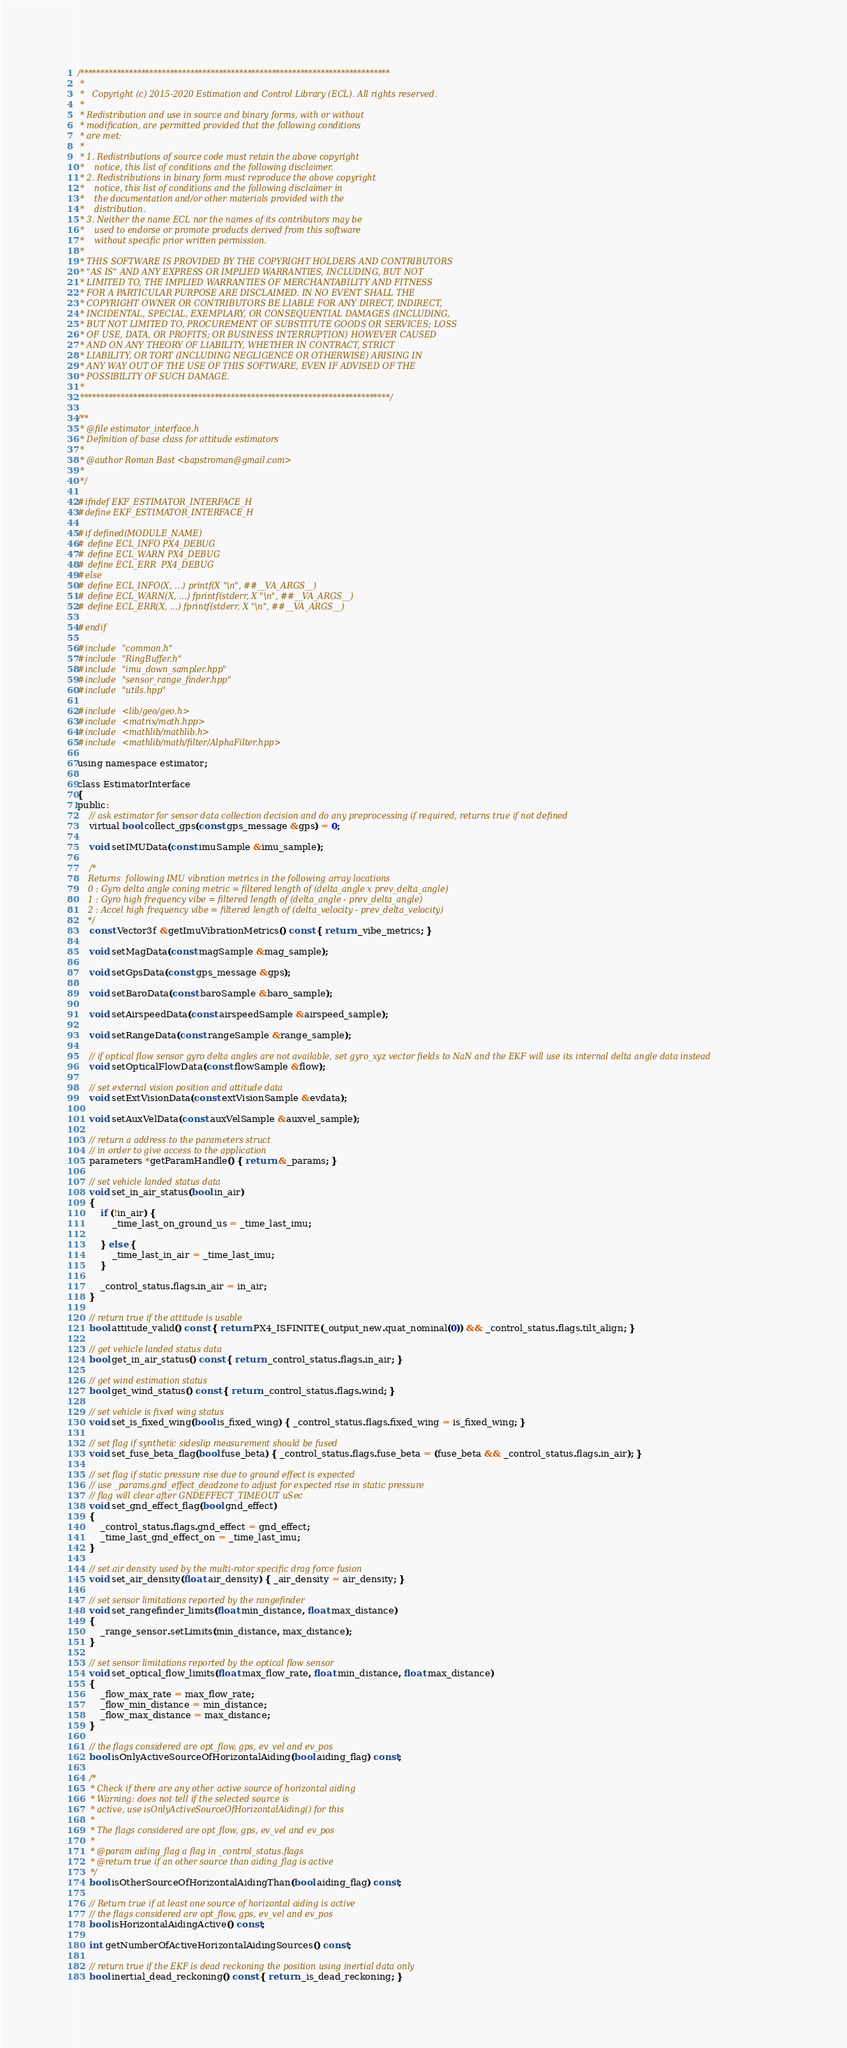<code> <loc_0><loc_0><loc_500><loc_500><_C_>/****************************************************************************
 *
 *   Copyright (c) 2015-2020 Estimation and Control Library (ECL). All rights reserved.
 *
 * Redistribution and use in source and binary forms, with or without
 * modification, are permitted provided that the following conditions
 * are met:
 *
 * 1. Redistributions of source code must retain the above copyright
 *    notice, this list of conditions and the following disclaimer.
 * 2. Redistributions in binary form must reproduce the above copyright
 *    notice, this list of conditions and the following disclaimer in
 *    the documentation and/or other materials provided with the
 *    distribution.
 * 3. Neither the name ECL nor the names of its contributors may be
 *    used to endorse or promote products derived from this software
 *    without specific prior written permission.
 *
 * THIS SOFTWARE IS PROVIDED BY THE COPYRIGHT HOLDERS AND CONTRIBUTORS
 * "AS IS" AND ANY EXPRESS OR IMPLIED WARRANTIES, INCLUDING, BUT NOT
 * LIMITED TO, THE IMPLIED WARRANTIES OF MERCHANTABILITY AND FITNESS
 * FOR A PARTICULAR PURPOSE ARE DISCLAIMED. IN NO EVENT SHALL THE
 * COPYRIGHT OWNER OR CONTRIBUTORS BE LIABLE FOR ANY DIRECT, INDIRECT,
 * INCIDENTAL, SPECIAL, EXEMPLARY, OR CONSEQUENTIAL DAMAGES (INCLUDING,
 * BUT NOT LIMITED TO, PROCUREMENT OF SUBSTITUTE GOODS OR SERVICES; LOSS
 * OF USE, DATA, OR PROFITS; OR BUSINESS INTERRUPTION) HOWEVER CAUSED
 * AND ON ANY THEORY OF LIABILITY, WHETHER IN CONTRACT, STRICT
 * LIABILITY, OR TORT (INCLUDING NEGLIGENCE OR OTHERWISE) ARISING IN
 * ANY WAY OUT OF THE USE OF THIS SOFTWARE, EVEN IF ADVISED OF THE
 * POSSIBILITY OF SUCH DAMAGE.
 *
 ****************************************************************************/

/**
 * @file estimator_interface.h
 * Definition of base class for attitude estimators
 *
 * @author Roman Bast <bapstroman@gmail.com>
 *
 */

#ifndef EKF_ESTIMATOR_INTERFACE_H
#define EKF_ESTIMATOR_INTERFACE_H

#if defined(MODULE_NAME)
# define ECL_INFO PX4_DEBUG
# define ECL_WARN PX4_DEBUG
# define ECL_ERR  PX4_DEBUG
#else
# define ECL_INFO(X, ...) printf(X "\n", ##__VA_ARGS__)
# define ECL_WARN(X, ...) fprintf(stderr, X "\n", ##__VA_ARGS__)
# define ECL_ERR(X, ...) fprintf(stderr, X "\n", ##__VA_ARGS__)

#endif

#include "common.h"
#include "RingBuffer.h"
#include "imu_down_sampler.hpp"
#include "sensor_range_finder.hpp"
#include "utils.hpp"

#include <lib/geo/geo.h>
#include <matrix/math.hpp>
#include <mathlib/mathlib.h>
#include <mathlib/math/filter/AlphaFilter.hpp>

using namespace estimator;

class EstimatorInterface
{
public:
	// ask estimator for sensor data collection decision and do any preprocessing if required, returns true if not defined
	virtual bool collect_gps(const gps_message &gps) = 0;

	void setIMUData(const imuSample &imu_sample);

	/*
	Returns  following IMU vibration metrics in the following array locations
	0 : Gyro delta angle coning metric = filtered length of (delta_angle x prev_delta_angle)
	1 : Gyro high frequency vibe = filtered length of (delta_angle - prev_delta_angle)
	2 : Accel high frequency vibe = filtered length of (delta_velocity - prev_delta_velocity)
	*/
	const Vector3f &getImuVibrationMetrics() const { return _vibe_metrics; }

	void setMagData(const magSample &mag_sample);

	void setGpsData(const gps_message &gps);

	void setBaroData(const baroSample &baro_sample);

	void setAirspeedData(const airspeedSample &airspeed_sample);

	void setRangeData(const rangeSample &range_sample);

	// if optical flow sensor gyro delta angles are not available, set gyro_xyz vector fields to NaN and the EKF will use its internal delta angle data instead
	void setOpticalFlowData(const flowSample &flow);

	// set external vision position and attitude data
	void setExtVisionData(const extVisionSample &evdata);

	void setAuxVelData(const auxVelSample &auxvel_sample);

	// return a address to the parameters struct
	// in order to give access to the application
	parameters *getParamHandle() { return &_params; }

	// set vehicle landed status data
	void set_in_air_status(bool in_air)
	{
		if (!in_air) {
			_time_last_on_ground_us = _time_last_imu;

		} else {
			_time_last_in_air = _time_last_imu;
		}

		_control_status.flags.in_air = in_air;
	}

	// return true if the attitude is usable
	bool attitude_valid() const { return PX4_ISFINITE(_output_new.quat_nominal(0)) && _control_status.flags.tilt_align; }

	// get vehicle landed status data
	bool get_in_air_status() const { return _control_status.flags.in_air; }

	// get wind estimation status
	bool get_wind_status() const { return _control_status.flags.wind; }

	// set vehicle is fixed wing status
	void set_is_fixed_wing(bool is_fixed_wing) { _control_status.flags.fixed_wing = is_fixed_wing; }

	// set flag if synthetic sideslip measurement should be fused
	void set_fuse_beta_flag(bool fuse_beta) { _control_status.flags.fuse_beta = (fuse_beta && _control_status.flags.in_air); }

	// set flag if static pressure rise due to ground effect is expected
	// use _params.gnd_effect_deadzone to adjust for expected rise in static pressure
	// flag will clear after GNDEFFECT_TIMEOUT uSec
	void set_gnd_effect_flag(bool gnd_effect)
	{
		_control_status.flags.gnd_effect = gnd_effect;
		_time_last_gnd_effect_on = _time_last_imu;
	}

	// set air density used by the multi-rotor specific drag force fusion
	void set_air_density(float air_density) { _air_density = air_density; }

	// set sensor limitations reported by the rangefinder
	void set_rangefinder_limits(float min_distance, float max_distance)
	{
		_range_sensor.setLimits(min_distance, max_distance);
	}

	// set sensor limitations reported by the optical flow sensor
	void set_optical_flow_limits(float max_flow_rate, float min_distance, float max_distance)
	{
		_flow_max_rate = max_flow_rate;
		_flow_min_distance = min_distance;
		_flow_max_distance = max_distance;
	}

	// the flags considered are opt_flow, gps, ev_vel and ev_pos
	bool isOnlyActiveSourceOfHorizontalAiding(bool aiding_flag) const;

	/*
	 * Check if there are any other active source of horizontal aiding
	 * Warning: does not tell if the selected source is
	 * active, use isOnlyActiveSourceOfHorizontalAiding() for this
	 *
	 * The flags considered are opt_flow, gps, ev_vel and ev_pos
	 *
	 * @param aiding_flag a flag in _control_status.flags
	 * @return true if an other source than aiding_flag is active
	 */
	bool isOtherSourceOfHorizontalAidingThan(bool aiding_flag) const;

	// Return true if at least one source of horizontal aiding is active
	// the flags considered are opt_flow, gps, ev_vel and ev_pos
	bool isHorizontalAidingActive() const;

	int getNumberOfActiveHorizontalAidingSources() const;

	// return true if the EKF is dead reckoning the position using inertial data only
	bool inertial_dead_reckoning() const { return _is_dead_reckoning; }
</code> 